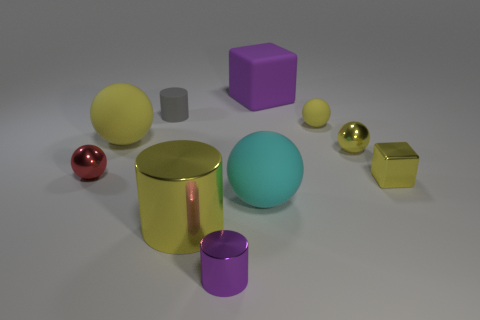How many yellow spheres must be subtracted to get 1 yellow spheres? 2 Subtract all red cubes. How many yellow spheres are left? 3 Subtract all cyan spheres. How many spheres are left? 4 Subtract all gray spheres. Subtract all yellow blocks. How many spheres are left? 5 Subtract all cylinders. How many objects are left? 7 Subtract all green matte objects. Subtract all small gray rubber objects. How many objects are left? 9 Add 3 small purple things. How many small purple things are left? 4 Add 9 cyan blocks. How many cyan blocks exist? 9 Subtract 0 blue cylinders. How many objects are left? 10 